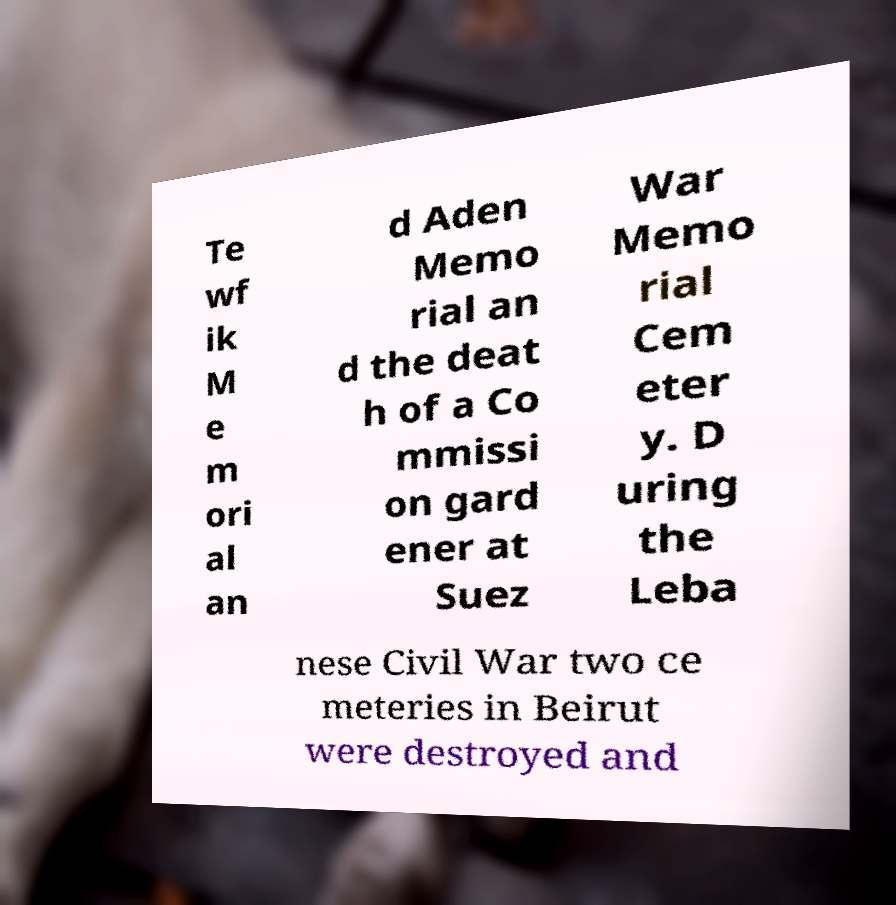There's text embedded in this image that I need extracted. Can you transcribe it verbatim? Te wf ik M e m ori al an d Aden Memo rial an d the deat h of a Co mmissi on gard ener at Suez War Memo rial Cem eter y. D uring the Leba nese Civil War two ce meteries in Beirut were destroyed and 